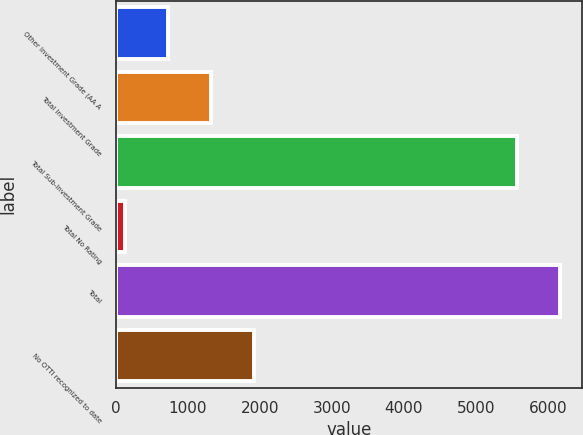<chart> <loc_0><loc_0><loc_500><loc_500><bar_chart><fcel>Other Investment Grade (AA A<fcel>Total Investment Grade<fcel>Total Sub-Investment Grade<fcel>Total No Rating<fcel>Total<fcel>No OTTI recognized to date<nl><fcel>723.2<fcel>1321.4<fcel>5563<fcel>125<fcel>6161.2<fcel>1919.6<nl></chart> 